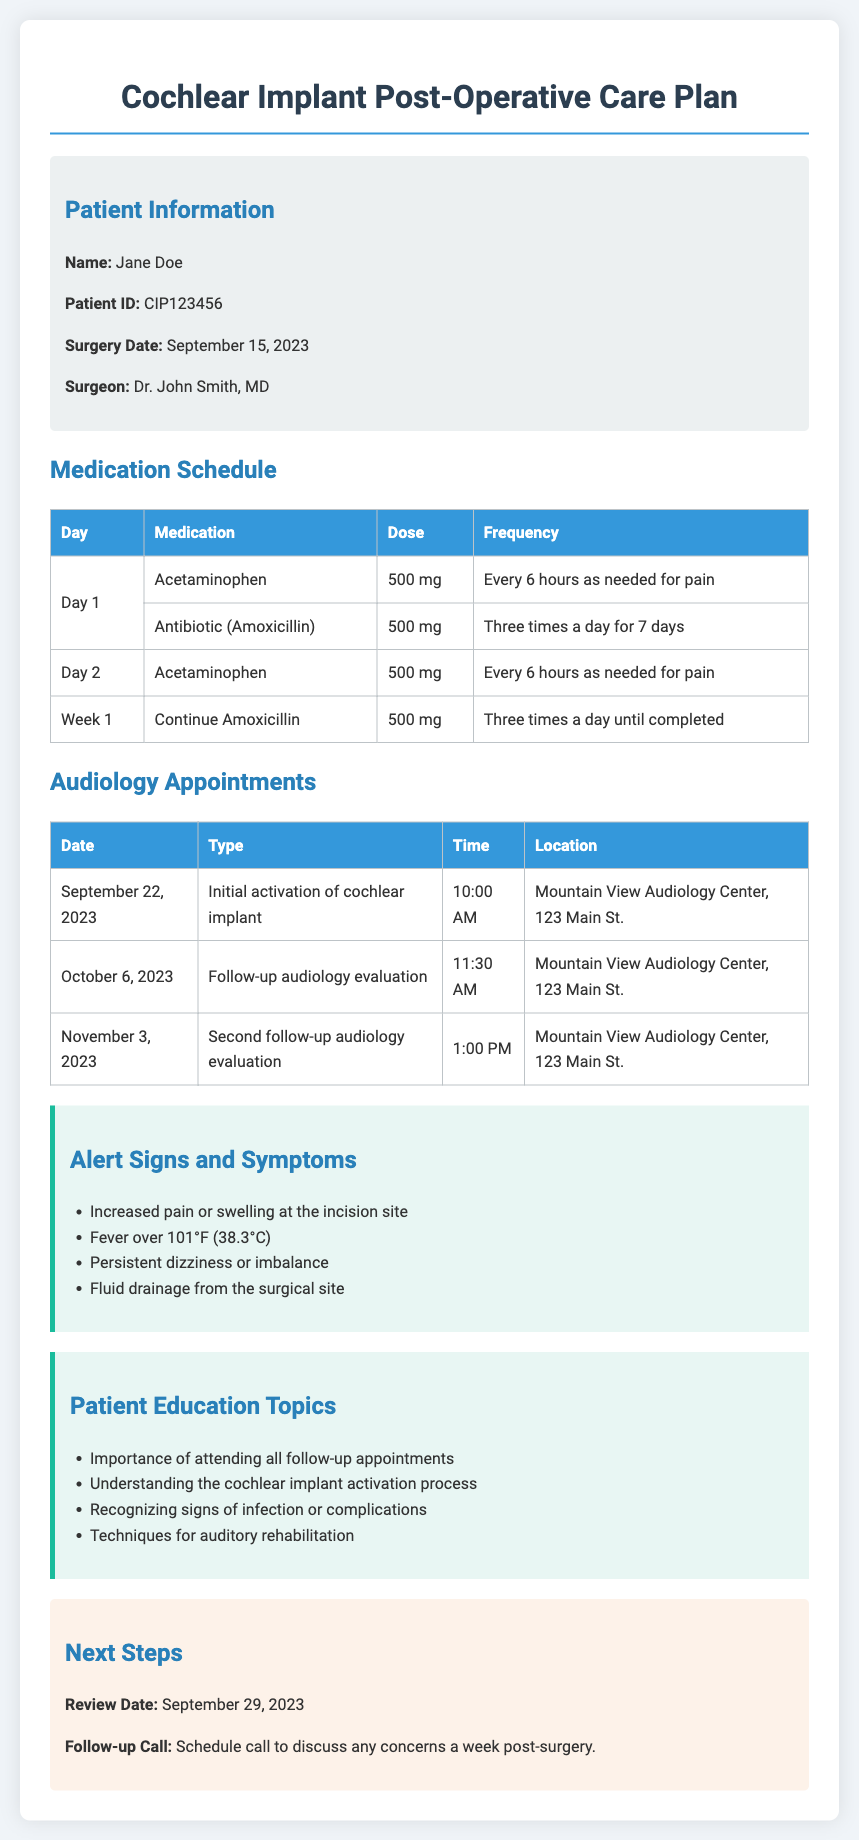What is the patient's name? The patient's name is provided in the patient information section of the document.
Answer: Jane Doe What is the date of the initial activation appointment? The date for the initial activation appointment is clearly noted in the audiology appointments table.
Answer: September 22, 2023 Which medication is prescribed for pain management? The medication for pain management is listed in the medication schedule section of the document.
Answer: Acetaminophen How often should Amoxicillin be taken during the first week? The frequency for taking Amoxicillin is specified in the medication schedule table.
Answer: Three times a day for 7 days What are two alert signs to monitor post-surgery? Two signs can be found in the alert signs and symptoms section of the document.
Answer: Increased pain or swelling at the incision site, Fever over 101°F How many follow-up audiology evaluations are scheduled? The total number of follow-up evaluations can be tallied from the audiology appointments table.
Answer: Two What is the review date mentioned in the next steps? The review date is explicitly stated in the next steps section of the document.
Answer: September 29, 2023 What is the main focus of the patient education topics? The patient education topics cover important aspects outlined specifically in the education topics section.
Answer: Importance of attending all follow-up appointments 